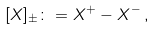<formula> <loc_0><loc_0><loc_500><loc_500>[ X ] _ { \pm } \colon = X ^ { + } - X ^ { - } \, ,</formula> 